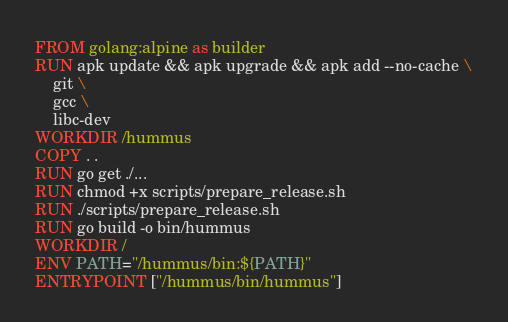Convert code to text. <code><loc_0><loc_0><loc_500><loc_500><_Dockerfile_>FROM golang:alpine as builder
RUN apk update && apk upgrade && apk add --no-cache \
    git \
    gcc \
    libc-dev
WORKDIR /hummus
COPY . .
RUN go get ./...
RUN chmod +x scripts/prepare_release.sh
RUN ./scripts/prepare_release.sh
RUN go build -o bin/hummus
WORKDIR /
ENV PATH="/hummus/bin:${PATH}"
ENTRYPOINT ["/hummus/bin/hummus"]</code> 